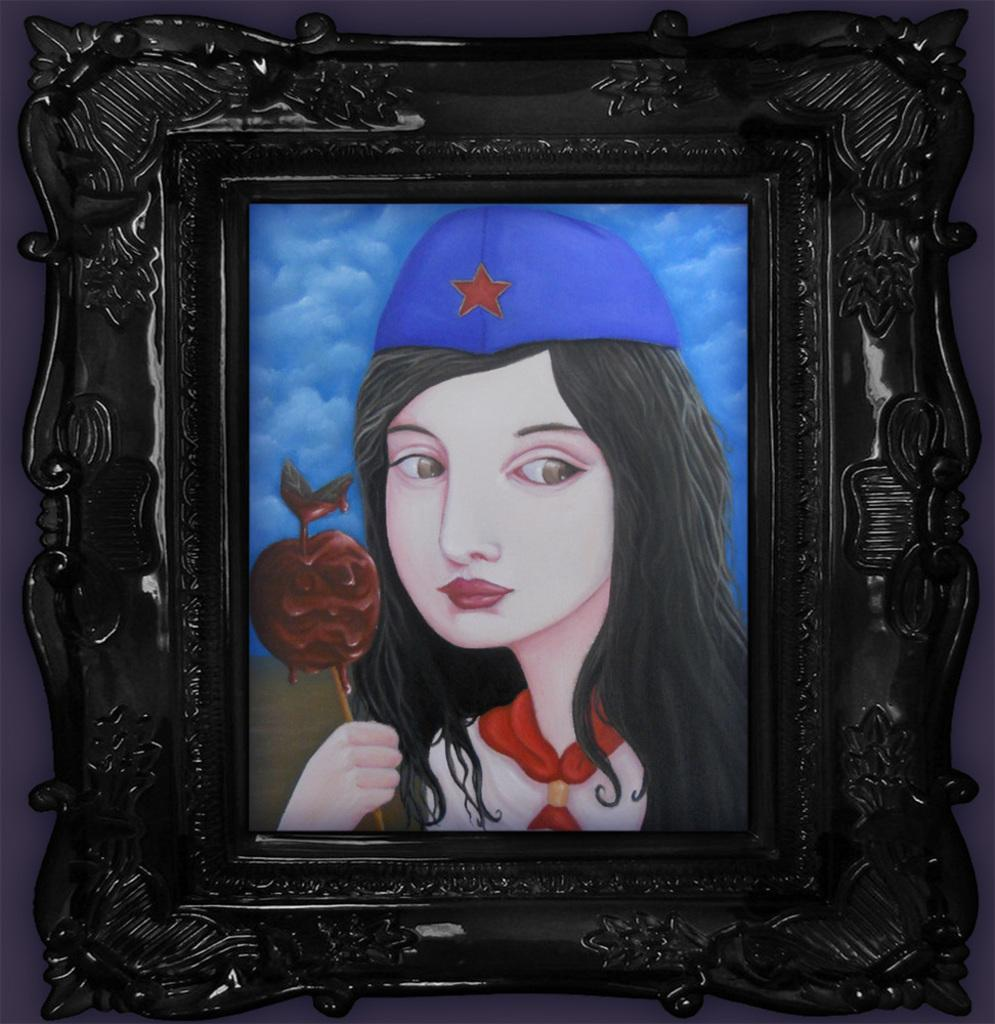What is the main object in the image? There is a frame in the image. What is inside the frame? The frame contains a painting. What is the subject of the painting? The painting depicts a woman. How many babies are visible in the painting? There are no babies depicted in the painting; it features a woman. What type of dress is the woman wearing in the painting? The painting does not show the woman wearing a dress; it only depicts her from the shoulders up. 